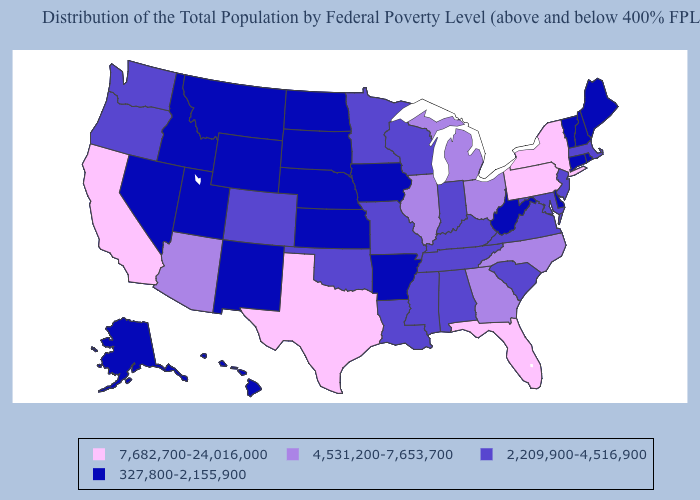Name the states that have a value in the range 7,682,700-24,016,000?
Keep it brief. California, Florida, New York, Pennsylvania, Texas. Name the states that have a value in the range 2,209,900-4,516,900?
Keep it brief. Alabama, Colorado, Indiana, Kentucky, Louisiana, Maryland, Massachusetts, Minnesota, Mississippi, Missouri, New Jersey, Oklahoma, Oregon, South Carolina, Tennessee, Virginia, Washington, Wisconsin. Name the states that have a value in the range 4,531,200-7,653,700?
Keep it brief. Arizona, Georgia, Illinois, Michigan, North Carolina, Ohio. What is the highest value in the Northeast ?
Be succinct. 7,682,700-24,016,000. Name the states that have a value in the range 2,209,900-4,516,900?
Write a very short answer. Alabama, Colorado, Indiana, Kentucky, Louisiana, Maryland, Massachusetts, Minnesota, Mississippi, Missouri, New Jersey, Oklahoma, Oregon, South Carolina, Tennessee, Virginia, Washington, Wisconsin. Does Utah have the same value as Delaware?
Give a very brief answer. Yes. Does New Jersey have a lower value than Tennessee?
Give a very brief answer. No. What is the highest value in the USA?
Concise answer only. 7,682,700-24,016,000. What is the highest value in the USA?
Concise answer only. 7,682,700-24,016,000. Name the states that have a value in the range 327,800-2,155,900?
Short answer required. Alaska, Arkansas, Connecticut, Delaware, Hawaii, Idaho, Iowa, Kansas, Maine, Montana, Nebraska, Nevada, New Hampshire, New Mexico, North Dakota, Rhode Island, South Dakota, Utah, Vermont, West Virginia, Wyoming. Among the states that border Arkansas , does Texas have the highest value?
Keep it brief. Yes. What is the highest value in states that border Tennessee?
Quick response, please. 4,531,200-7,653,700. Name the states that have a value in the range 4,531,200-7,653,700?
Concise answer only. Arizona, Georgia, Illinois, Michigan, North Carolina, Ohio. Does the map have missing data?
Write a very short answer. No. 